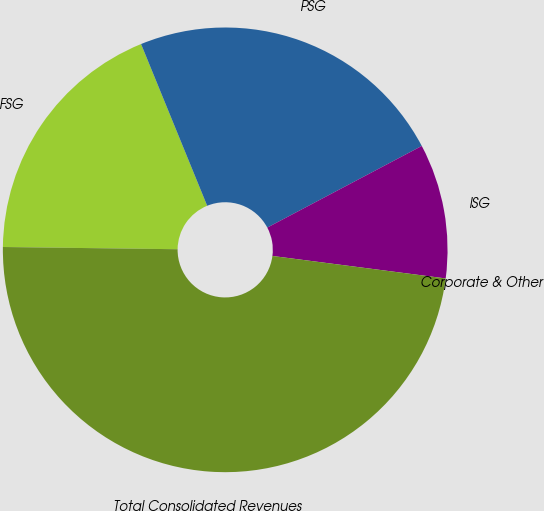<chart> <loc_0><loc_0><loc_500><loc_500><pie_chart><fcel>FSG<fcel>PSG<fcel>ISG<fcel>Corporate & Other<fcel>Total Consolidated Revenues<nl><fcel>18.62%<fcel>23.44%<fcel>9.79%<fcel>0.0%<fcel>48.15%<nl></chart> 